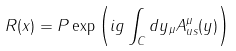Convert formula to latex. <formula><loc_0><loc_0><loc_500><loc_500>R ( x ) = P \exp \left ( i g \int _ { C } d y _ { \mu } A _ { u s } ^ { \mu } ( y ) \right )</formula> 